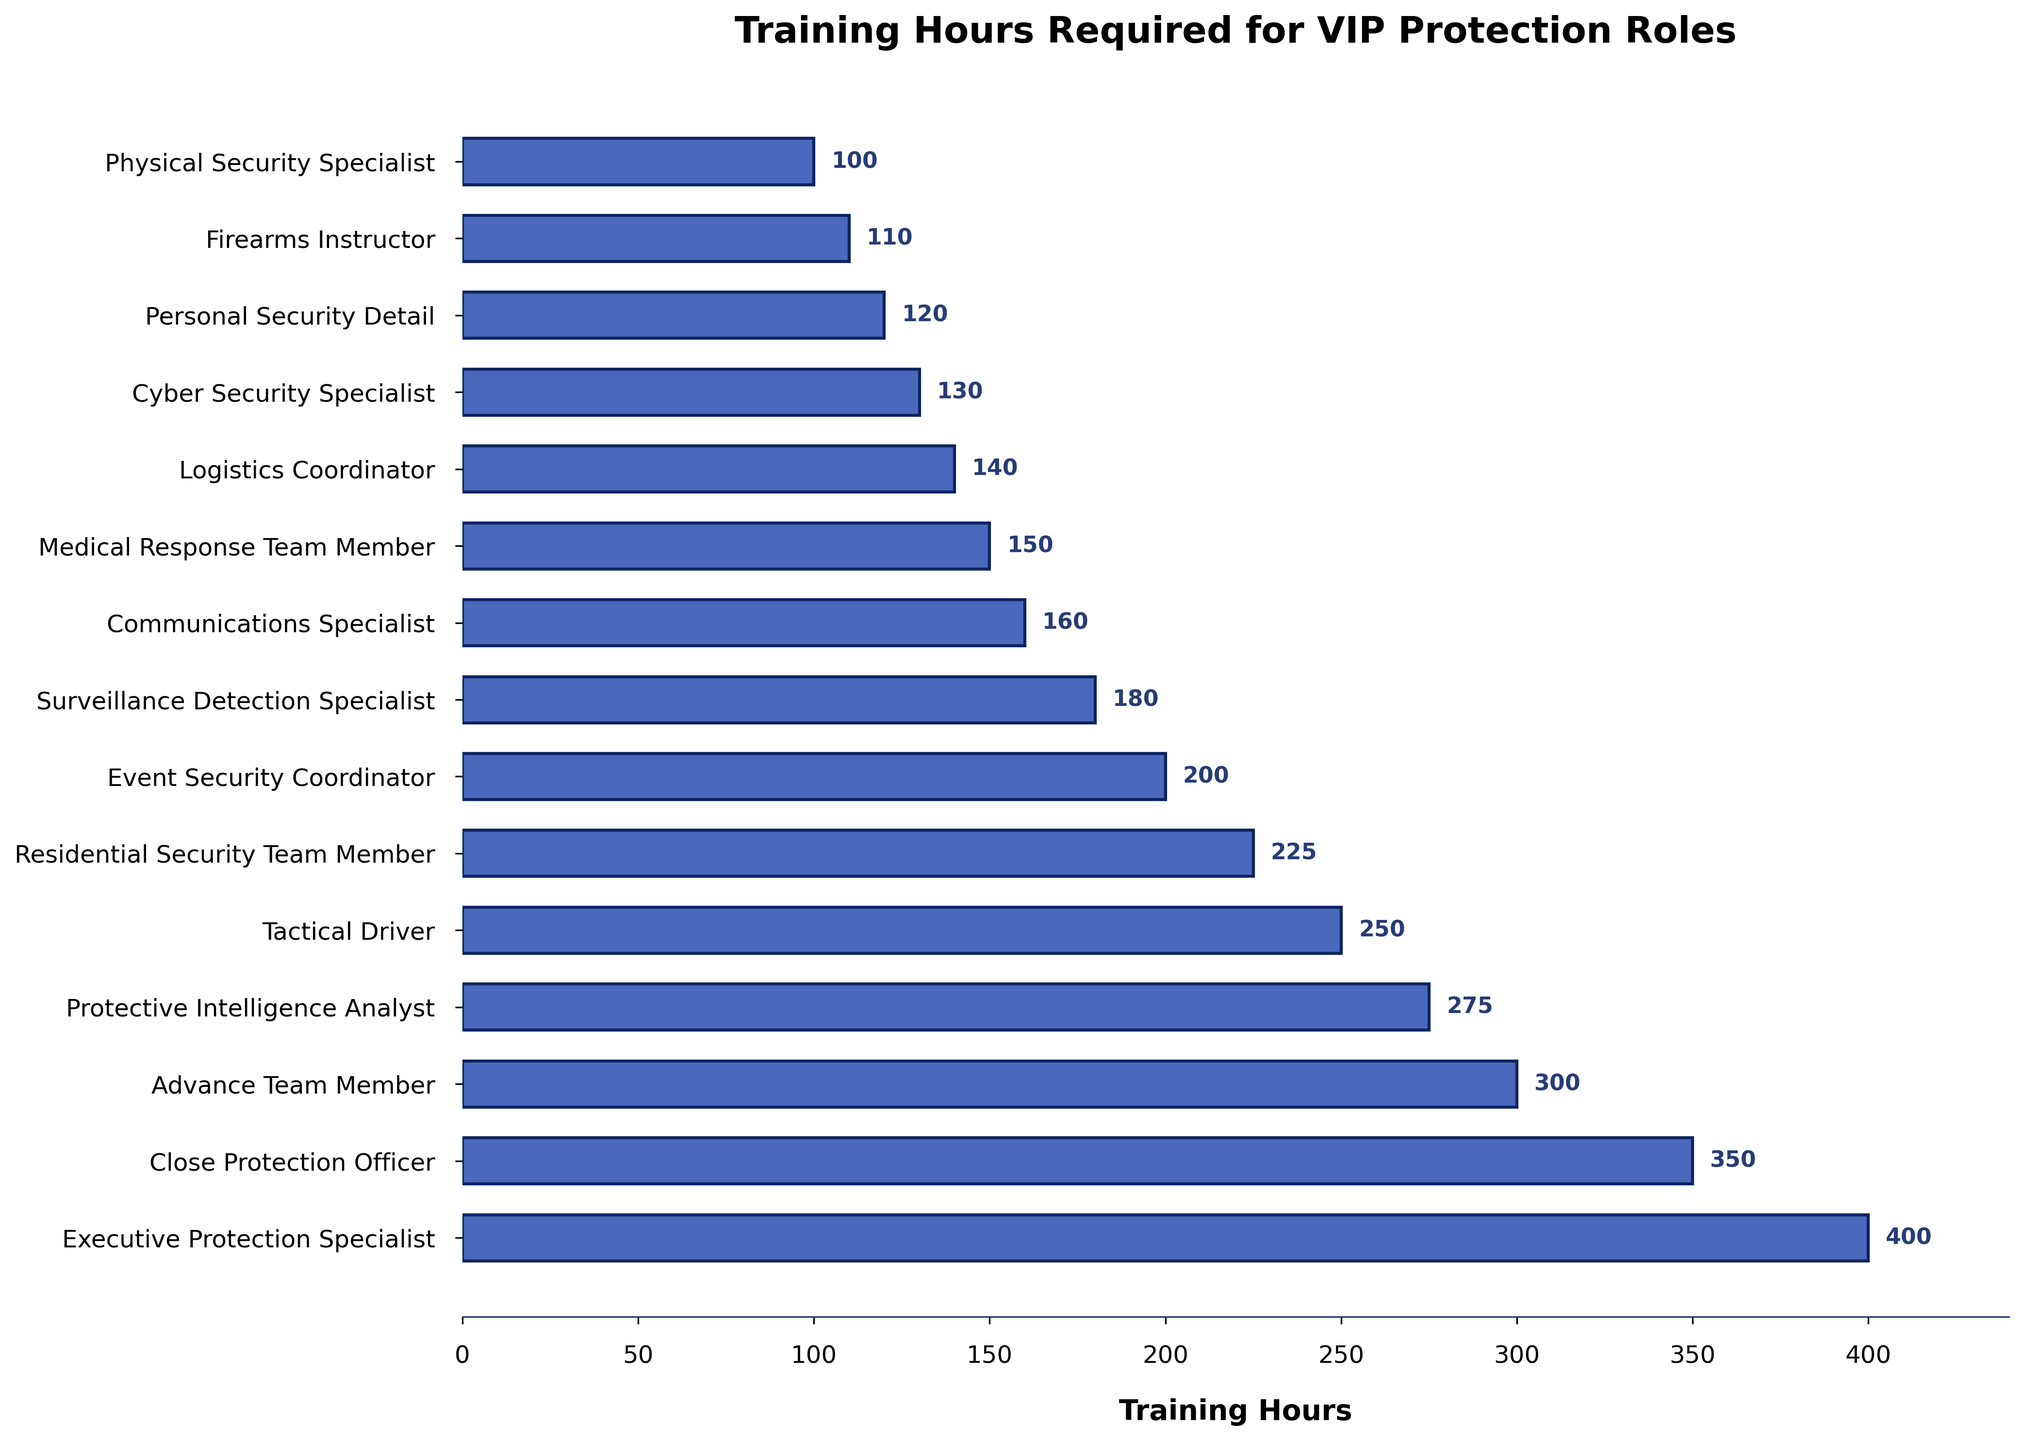What's the training hours required for an Executive Protection Specialist? The figure shows a horizontal bar for each role with the training hours labeled. The bar for "Executive Protection Specialist" is the longest and labeled with its value.
Answer: 400 Which role has the least training hours? The figure orders roles by training hours in descending order. The shortest bar, representing the least training hours, is for the "Physical Security Specialist."
Answer: Physical Security Specialist What is the difference in training hours between a Close Protection Officer and a Cyber Security Specialist? The bar for "Close Protection Officer" shows 350 training hours, and the bar for "Cyber Security Specialist" shows 130 training hours. The difference is calculated as 350 - 130.
Answer: 220 Which roles require training hours between 200 and 300? By examining the bars that fall within the 200 to 300 range, the roles "Protective Intelligence Analyst," "Tactical Driver," "Residential Security Team Member," and "Event Security Coordinator" fit in this range.
Answer: Protective Intelligence Analyst, Tactical Driver, Residential Security Team Member, Event Security Coordinator What's the median training hours for all the roles? To find the median, list the training hours in ascending order and find the middle value. The sorted hours are: 100, 110, 120, 130, 140, 150, 160, 180, 200, 225, 250, 275, 300, 350, 400. The median training hours are the 8th value in the ordered list since there are 15 values.
Answer: 180 Which roles have training hours greater than 275? The bars representing more than 275 hours are for "Executive Protection Specialist," "Close Protection Officer," "Advance Team Member," and "Protective Intelligence Analyst."
Answer: Executive Protection Specialist, Close Protection Officer, Advance Team Member, Protective Intelligence Analyst How much more training does a Medical Response Team Member need compared to a Logistics Coordinator? The training hours for "Medical Response Team Member" is 150 and for "Logistics Coordinator" is 140, the difference is 150 - 140.
Answer: 10 What is the total training hours of the top three roles combined? The top three roles by training hours are "Executive Protection Specialist" (400 hours), "Close Protection Officer" (350 hours), and "Advance Team Member" (300 hours). Sum them up: 400 + 350 + 300.
Answer: 1050 Which role requires more training: a Surveillance Detection Specialist or a Communications Specialist? The bar for "Surveillance Detection Specialist" shows 180 training hours and the bar for "Communications Specialist" shows 160 training hours.
Answer: Surveillance Detection Specialist What's the average training hours required for all roles? Sum all the training hours and divide by the number of roles. Total hours = 400 + 350 + 300 + 275 + 250 + 225 + 200 + 180 + 160 + 150 + 140 + 130 + 120 + 110 + 100 = 3390. Average is 3390 / 15.
Answer: 226 